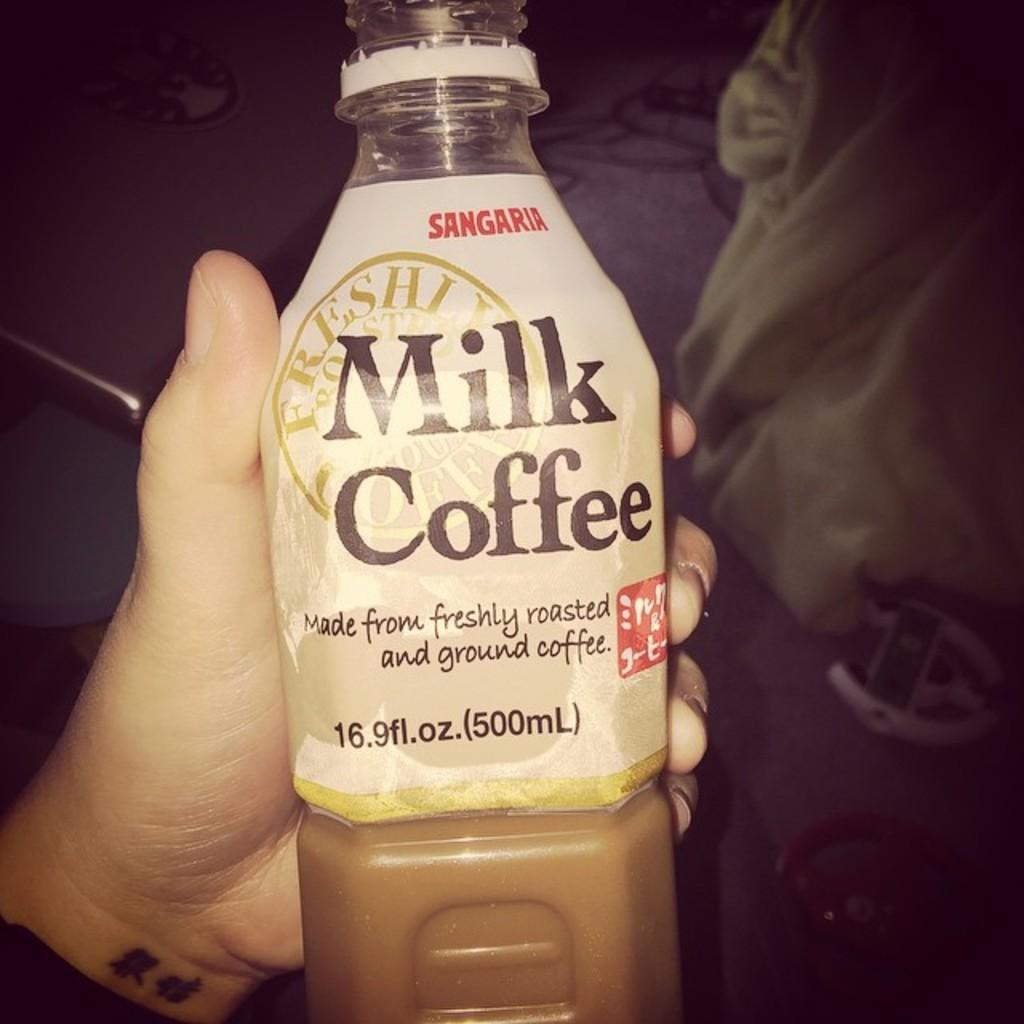What is on the left side of the image? There is a person on the left side of the image. What is the person holding in the image? The person is holding a bottle. What can be seen on the bottle? There is text on the bottle. What is inside the bottle? There is a drink inside the bottle. What type of bread is being used to support the organization in the image? There is no bread or organization present in the image. 